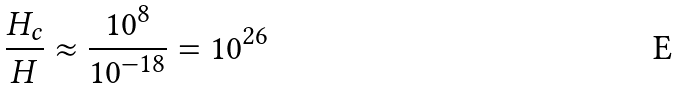<formula> <loc_0><loc_0><loc_500><loc_500>\frac { H _ { c } } { H } \approx \frac { 1 0 ^ { 8 } } { 1 0 ^ { - 1 8 } } = 1 0 ^ { 2 6 }</formula> 